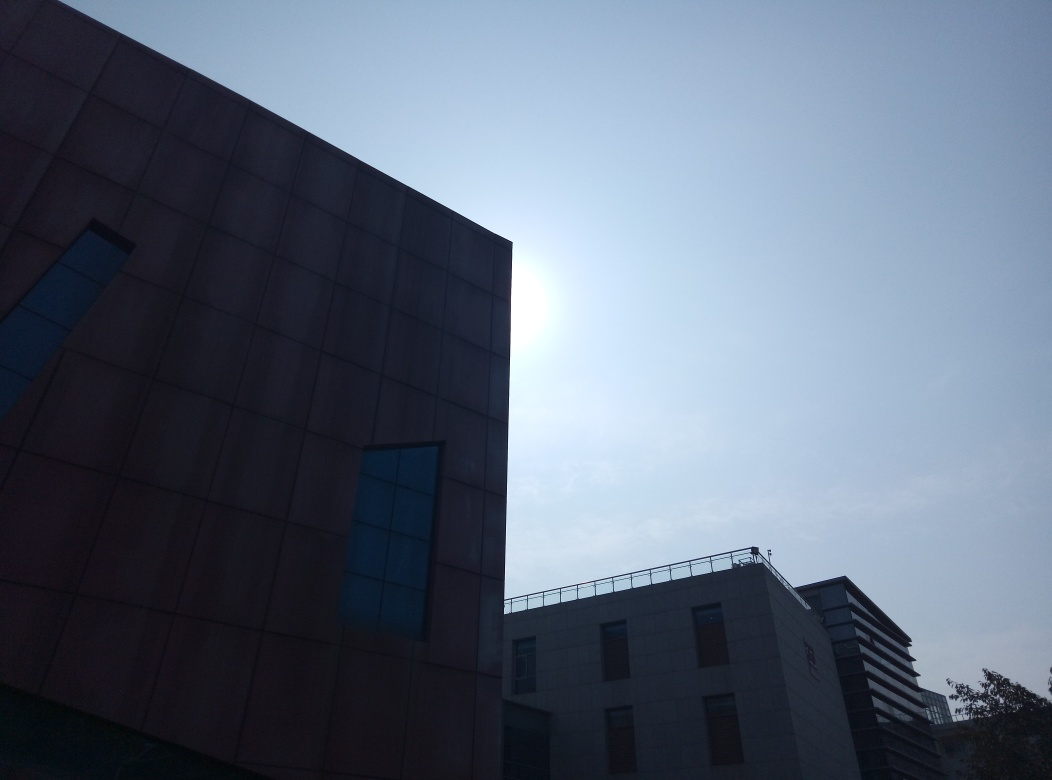Can you suggest how the lighting conditions affect the perception of the building's architecture? The backlighting from the sun creates a silhouette effect, emphasizing the building’s outline against a bright sky. This diminishes the visible details of the building's surface but highlights its shape and form, adding a dramatic and mysterious aura to the structure. Adjusting the exposure in this photograph might reveal more architectural details. 